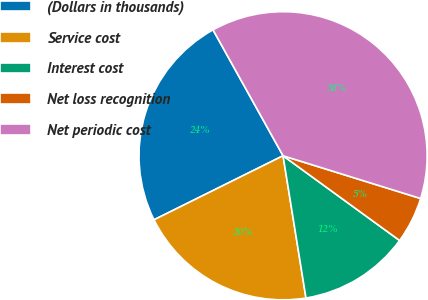Convert chart to OTSL. <chart><loc_0><loc_0><loc_500><loc_500><pie_chart><fcel>(Dollars in thousands)<fcel>Service cost<fcel>Interest cost<fcel>Net loss recognition<fcel>Net periodic cost<nl><fcel>24.25%<fcel>20.21%<fcel>12.45%<fcel>5.21%<fcel>37.87%<nl></chart> 